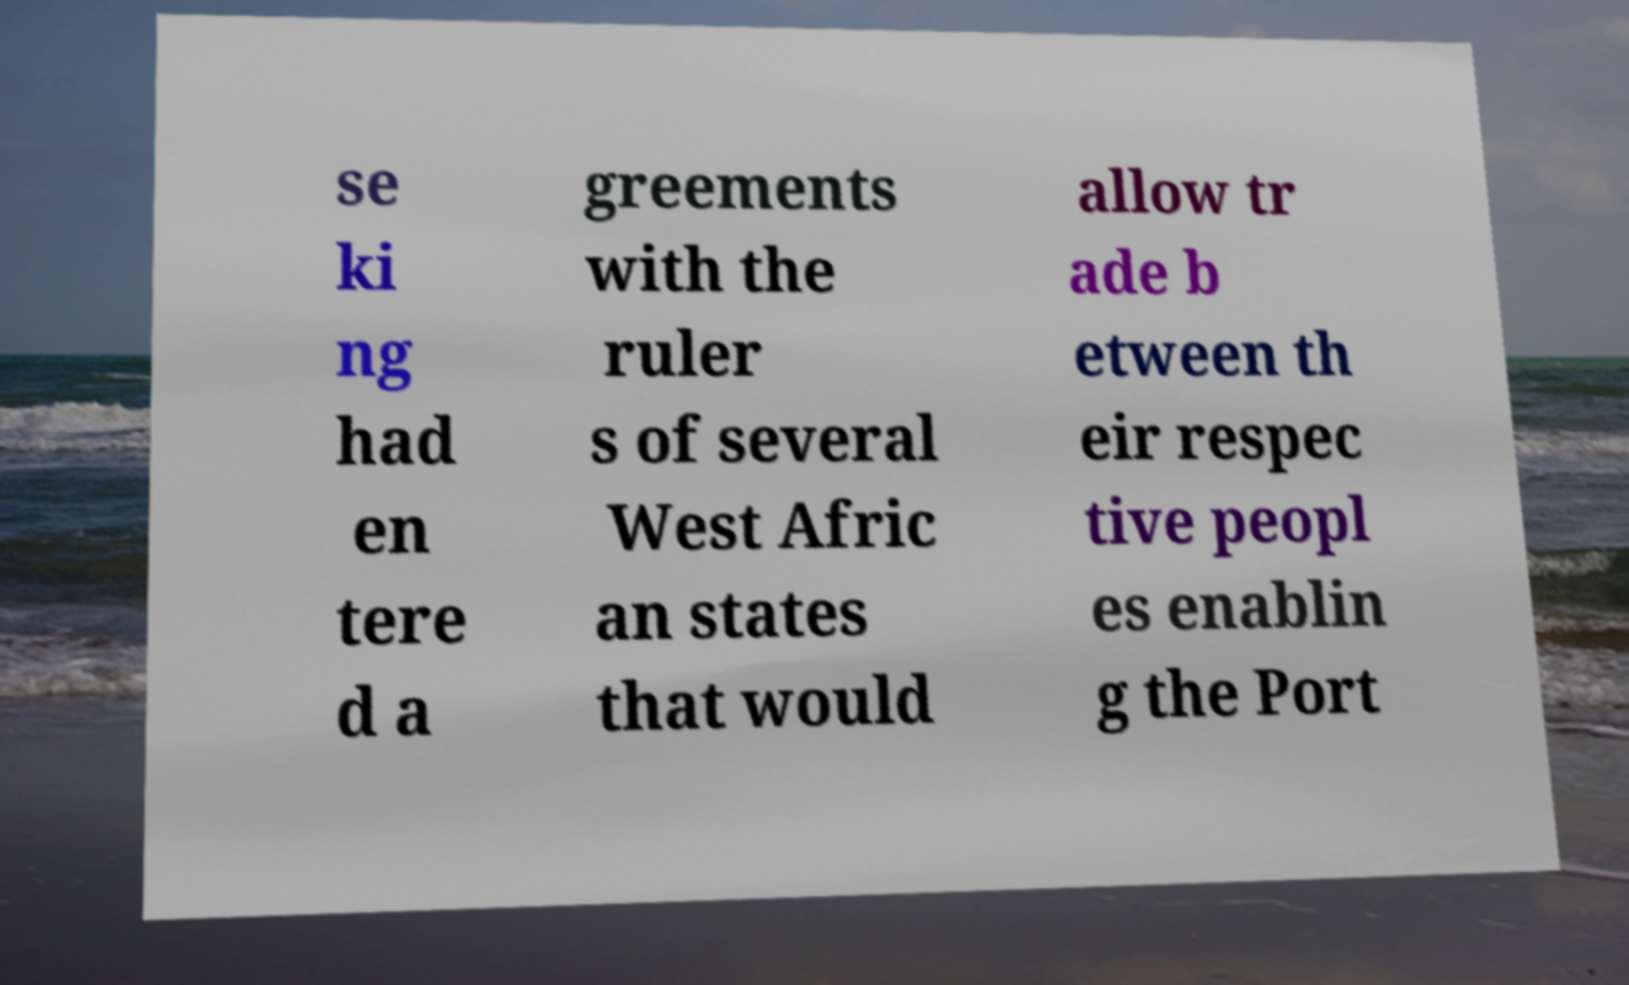Please read and relay the text visible in this image. What does it say? se ki ng had en tere d a greements with the ruler s of several West Afric an states that would allow tr ade b etween th eir respec tive peopl es enablin g the Port 